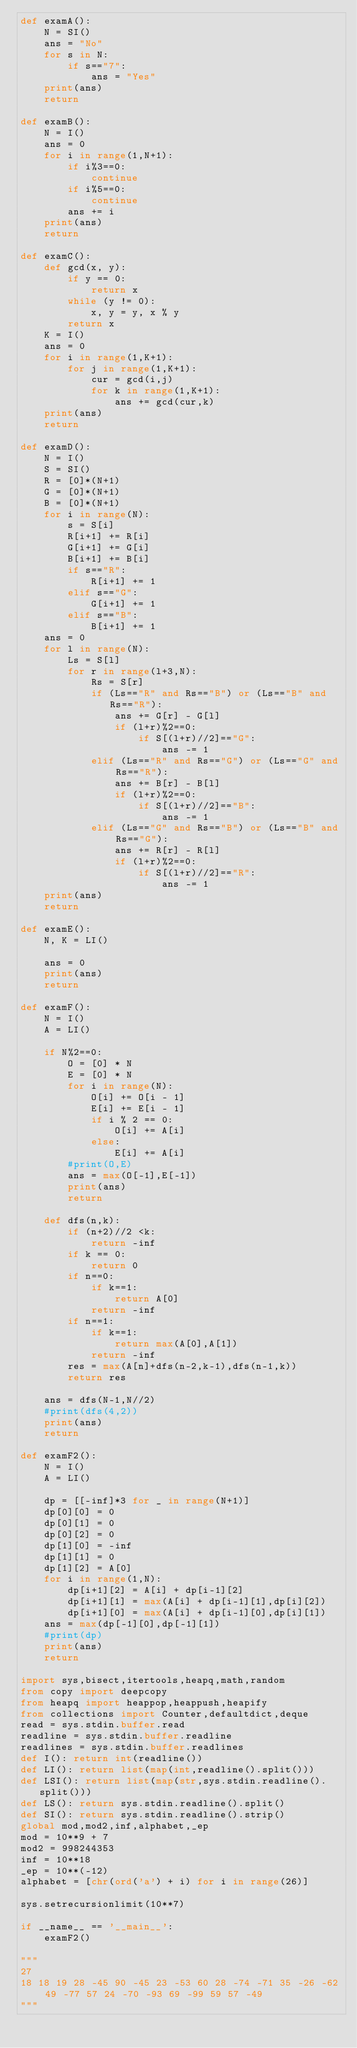<code> <loc_0><loc_0><loc_500><loc_500><_Python_>def examA():
    N = SI()
    ans = "No"
    for s in N:
        if s=="7":
            ans = "Yes"
    print(ans)
    return

def examB():
    N = I()
    ans = 0
    for i in range(1,N+1):
        if i%3==0:
            continue
        if i%5==0:
            continue
        ans += i
    print(ans)
    return

def examC():
    def gcd(x, y):
        if y == 0:
            return x
        while (y != 0):
            x, y = y, x % y
        return x
    K = I()
    ans = 0
    for i in range(1,K+1):
        for j in range(1,K+1):
            cur = gcd(i,j)
            for k in range(1,K+1):
                ans += gcd(cur,k)
    print(ans)
    return

def examD():
    N = I()
    S = SI()
    R = [0]*(N+1)
    G = [0]*(N+1)
    B = [0]*(N+1)
    for i in range(N):
        s = S[i]
        R[i+1] += R[i]
        G[i+1] += G[i]
        B[i+1] += B[i]
        if s=="R":
            R[i+1] += 1
        elif s=="G":
            G[i+1] += 1
        elif s=="B":
            B[i+1] += 1
    ans = 0
    for l in range(N):
        Ls = S[l]
        for r in range(l+3,N):
            Rs = S[r]
            if (Ls=="R" and Rs=="B") or (Ls=="B" and Rs=="R"):
                ans += G[r] - G[l]
                if (l+r)%2==0:
                    if S[(l+r)//2]=="G":
                        ans -= 1
            elif (Ls=="R" and Rs=="G") or (Ls=="G" and Rs=="R"):
                ans += B[r] - B[l]
                if (l+r)%2==0:
                    if S[(l+r)//2]=="B":
                        ans -= 1
            elif (Ls=="G" and Rs=="B") or (Ls=="B" and Rs=="G"):
                ans += R[r] - R[l]
                if (l+r)%2==0:
                    if S[(l+r)//2]=="R":
                        ans -= 1
    print(ans)
    return

def examE():
    N, K = LI()

    ans = 0
    print(ans)
    return

def examF():
    N = I()
    A = LI()

    if N%2==0:
        O = [0] * N
        E = [0] * N
        for i in range(N):
            O[i] += O[i - 1]
            E[i] += E[i - 1]
            if i % 2 == 0:
                O[i] += A[i]
            else:
                E[i] += A[i]
        #print(O,E)
        ans = max(O[-1],E[-1])
        print(ans)
        return

    def dfs(n,k):
        if (n+2)//2 <k:
            return -inf
        if k == 0:
            return 0
        if n==0:
            if k==1:
                return A[0]
            return -inf
        if n==1:
            if k==1:
                return max(A[0],A[1])
            return -inf
        res = max(A[n]+dfs(n-2,k-1),dfs(n-1,k))
        return res

    ans = dfs(N-1,N//2)
    #print(dfs(4,2))
    print(ans)
    return

def examF2():
    N = I()
    A = LI()

    dp = [[-inf]*3 for _ in range(N+1)]
    dp[0][0] = 0
    dp[0][1] = 0
    dp[0][2] = 0
    dp[1][0] = -inf
    dp[1][1] = 0
    dp[1][2] = A[0]
    for i in range(1,N):
        dp[i+1][2] = A[i] + dp[i-1][2]
        dp[i+1][1] = max(A[i] + dp[i-1][1],dp[i][2])
        dp[i+1][0] = max(A[i] + dp[i-1][0],dp[i][1])
    ans = max(dp[-1][0],dp[-1][1])
    #print(dp)
    print(ans)
    return

import sys,bisect,itertools,heapq,math,random
from copy import deepcopy
from heapq import heappop,heappush,heapify
from collections import Counter,defaultdict,deque
read = sys.stdin.buffer.read
readline = sys.stdin.buffer.readline
readlines = sys.stdin.buffer.readlines
def I(): return int(readline())
def LI(): return list(map(int,readline().split()))
def LSI(): return list(map(str,sys.stdin.readline().split()))
def LS(): return sys.stdin.readline().split()
def SI(): return sys.stdin.readline().strip()
global mod,mod2,inf,alphabet,_ep
mod = 10**9 + 7
mod2 = 998244353
inf = 10**18
_ep = 10**(-12)
alphabet = [chr(ord('a') + i) for i in range(26)]

sys.setrecursionlimit(10**7)

if __name__ == '__main__':
    examF2()

"""
27
18 18 19 28 -45 90 -45 23 -53 60 28 -74 -71 35 -26 -62 49 -77 57 24 -70 -93 69 -99 59 57 -49
"""</code> 